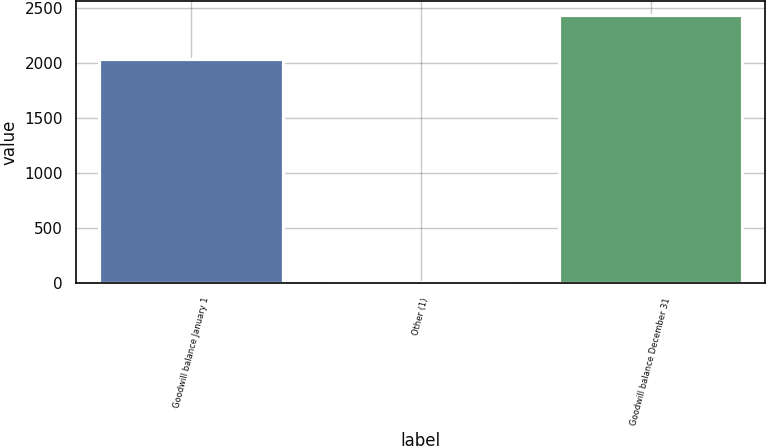Convert chart. <chart><loc_0><loc_0><loc_500><loc_500><bar_chart><fcel>Goodwill balance January 1<fcel>Other (1)<fcel>Goodwill balance December 31<nl><fcel>2033<fcel>15<fcel>2439.6<nl></chart> 